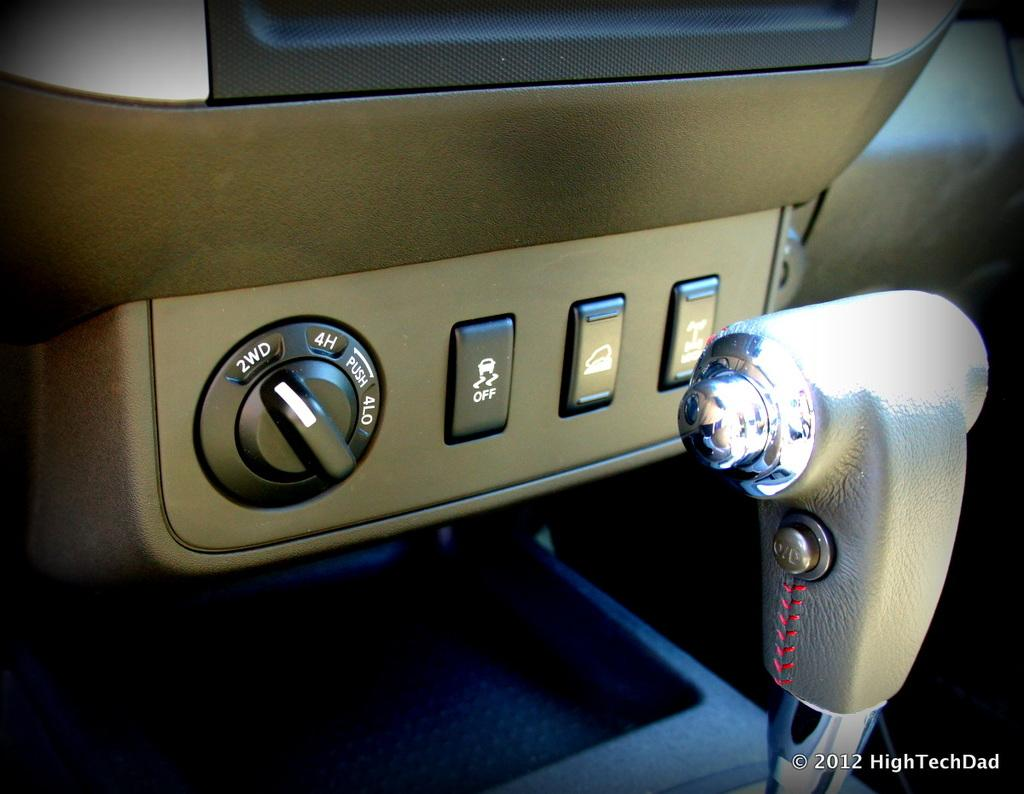What type of environment is shown in the image? The image is an inside view of a car. What is one of the main control devices in the image? There is a gear rod in the image. What other controls can be seen in the image? There are switches in the image. What is located on the right side of the image? There is some text on the right side of the image. What type of protest is taking place outside the car in the image? There is no protest visible in the image; it is an inside view of a car. Can you hear a whistle in the image? There is no whistle present in the image, as it is a still photograph. 